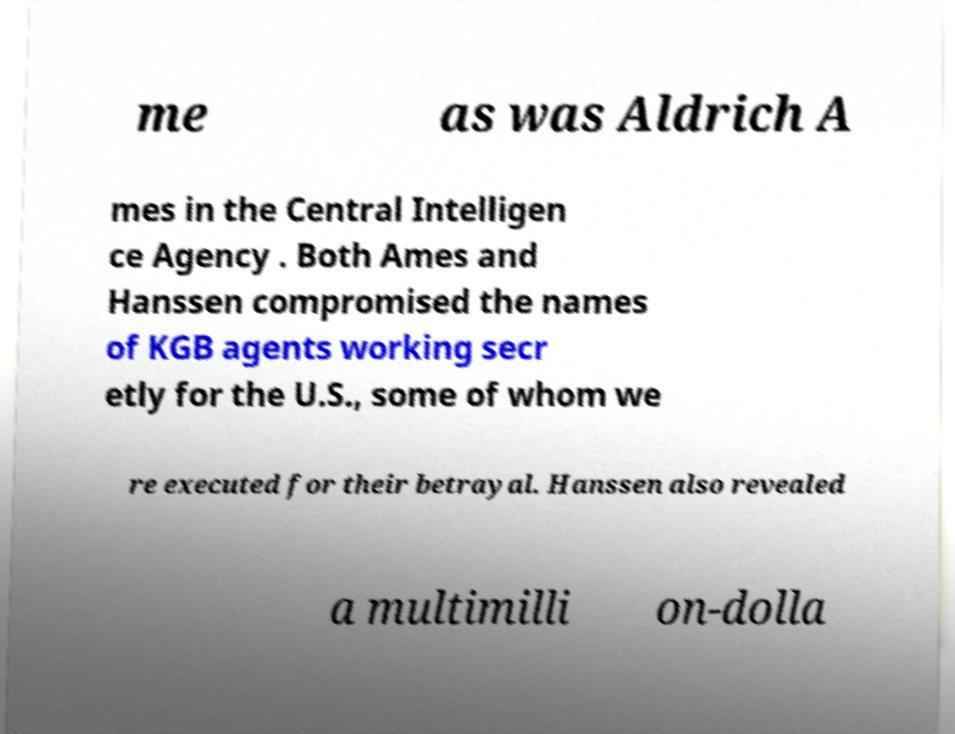Can you read and provide the text displayed in the image?This photo seems to have some interesting text. Can you extract and type it out for me? me as was Aldrich A mes in the Central Intelligen ce Agency . Both Ames and Hanssen compromised the names of KGB agents working secr etly for the U.S., some of whom we re executed for their betrayal. Hanssen also revealed a multimilli on-dolla 